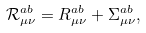<formula> <loc_0><loc_0><loc_500><loc_500>\mathcal { R } _ { \mu \nu } ^ { a b } = R _ { \mu \nu } ^ { a b } + \Sigma _ { \mu \nu } ^ { a b } ,</formula> 